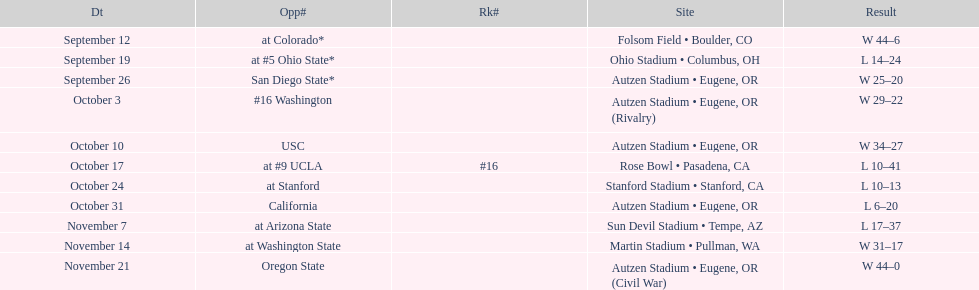Did the team win or lose more games? Win. 